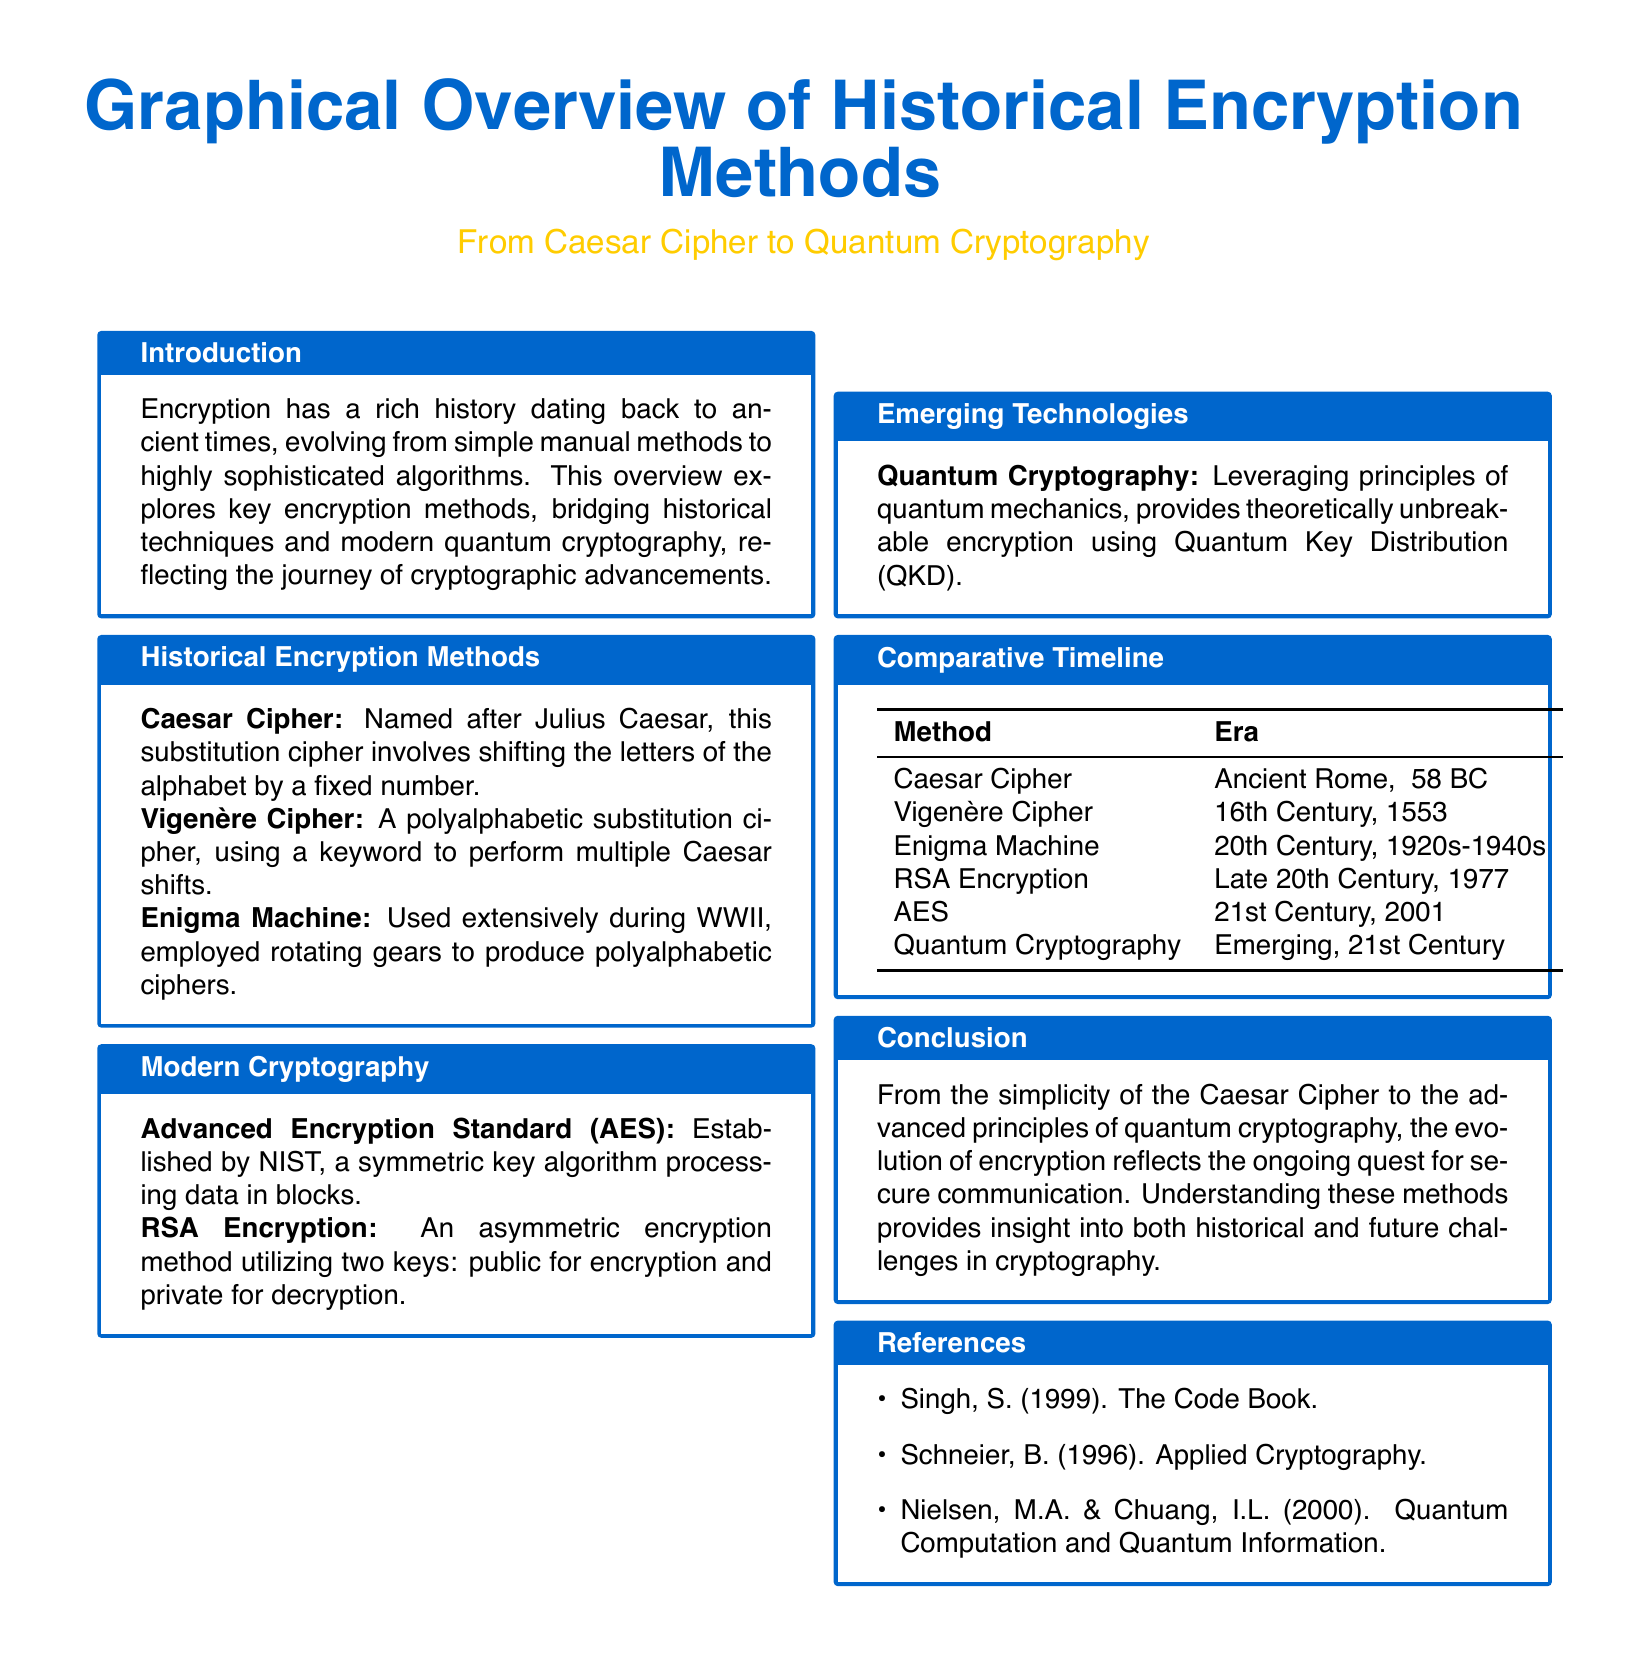what is the name of the first encryption method mentioned? The first encryption method mentioned in the document is the Caesar Cipher, which is a substitution cipher.
Answer: Caesar Cipher who is the Caesar Cipher named after? The Caesar Cipher is named after Julius Caesar, who used this method for communication.
Answer: Julius Caesar what year was the Vigenère Cipher introduced? The Vigenère Cipher was introduced in 1553, during the 16th Century.
Answer: 1553 which cryptographic method uses Quantum Key Distribution? Quantum Cryptography leverages Quantum Key Distribution for encryption.
Answer: Quantum Cryptography what is the time period of the Enigma Machine's use? The Enigma Machine was used during the 20th Century, specifically from the 1920s to the 1940s.
Answer: 1920s-1940s which encryption method is established by NIST? The encryption method established by NIST is the Advanced Encryption Standard (AES).
Answer: Advanced Encryption Standard (AES) what common principle does Quantum Cryptography utilize? Quantum Cryptography utilizes principles of quantum mechanics for encryption.
Answer: quantum mechanics how many historical encryption methods are listed in the document? The document lists a total of four historical encryption methods: Caesar Cipher, Vigenère Cipher, Enigma Machine, and RSA Encryption.
Answer: four what is the main theme of the document's conclusion? The theme of the conclusion discusses the evolution of encryption from simple methods to advanced ones like quantum cryptography.
Answer: evolution of encryption 